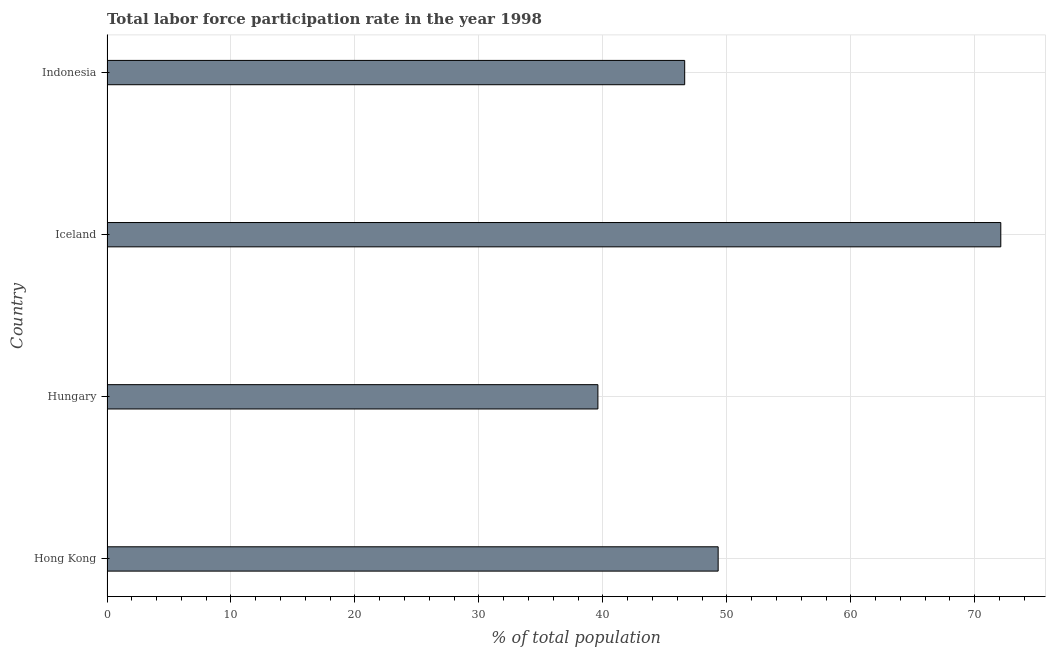Does the graph contain any zero values?
Your answer should be compact. No. What is the title of the graph?
Your answer should be very brief. Total labor force participation rate in the year 1998. What is the label or title of the X-axis?
Offer a terse response. % of total population. What is the label or title of the Y-axis?
Offer a very short reply. Country. What is the total labor force participation rate in Iceland?
Provide a short and direct response. 72.1. Across all countries, what is the maximum total labor force participation rate?
Give a very brief answer. 72.1. Across all countries, what is the minimum total labor force participation rate?
Give a very brief answer. 39.6. In which country was the total labor force participation rate minimum?
Your answer should be very brief. Hungary. What is the sum of the total labor force participation rate?
Offer a very short reply. 207.6. What is the difference between the total labor force participation rate in Hong Kong and Hungary?
Provide a short and direct response. 9.7. What is the average total labor force participation rate per country?
Make the answer very short. 51.9. What is the median total labor force participation rate?
Offer a very short reply. 47.95. In how many countries, is the total labor force participation rate greater than 16 %?
Make the answer very short. 4. What is the difference between the highest and the second highest total labor force participation rate?
Keep it short and to the point. 22.8. What is the difference between the highest and the lowest total labor force participation rate?
Your answer should be compact. 32.5. Are all the bars in the graph horizontal?
Your response must be concise. Yes. What is the difference between two consecutive major ticks on the X-axis?
Offer a very short reply. 10. Are the values on the major ticks of X-axis written in scientific E-notation?
Provide a succinct answer. No. What is the % of total population in Hong Kong?
Your answer should be very brief. 49.3. What is the % of total population of Hungary?
Offer a terse response. 39.6. What is the % of total population in Iceland?
Provide a succinct answer. 72.1. What is the % of total population of Indonesia?
Your answer should be very brief. 46.6. What is the difference between the % of total population in Hong Kong and Hungary?
Your answer should be compact. 9.7. What is the difference between the % of total population in Hong Kong and Iceland?
Your response must be concise. -22.8. What is the difference between the % of total population in Hong Kong and Indonesia?
Keep it short and to the point. 2.7. What is the difference between the % of total population in Hungary and Iceland?
Offer a very short reply. -32.5. What is the difference between the % of total population in Hungary and Indonesia?
Your answer should be very brief. -7. What is the ratio of the % of total population in Hong Kong to that in Hungary?
Your answer should be very brief. 1.25. What is the ratio of the % of total population in Hong Kong to that in Iceland?
Give a very brief answer. 0.68. What is the ratio of the % of total population in Hong Kong to that in Indonesia?
Ensure brevity in your answer.  1.06. What is the ratio of the % of total population in Hungary to that in Iceland?
Give a very brief answer. 0.55. What is the ratio of the % of total population in Iceland to that in Indonesia?
Keep it short and to the point. 1.55. 